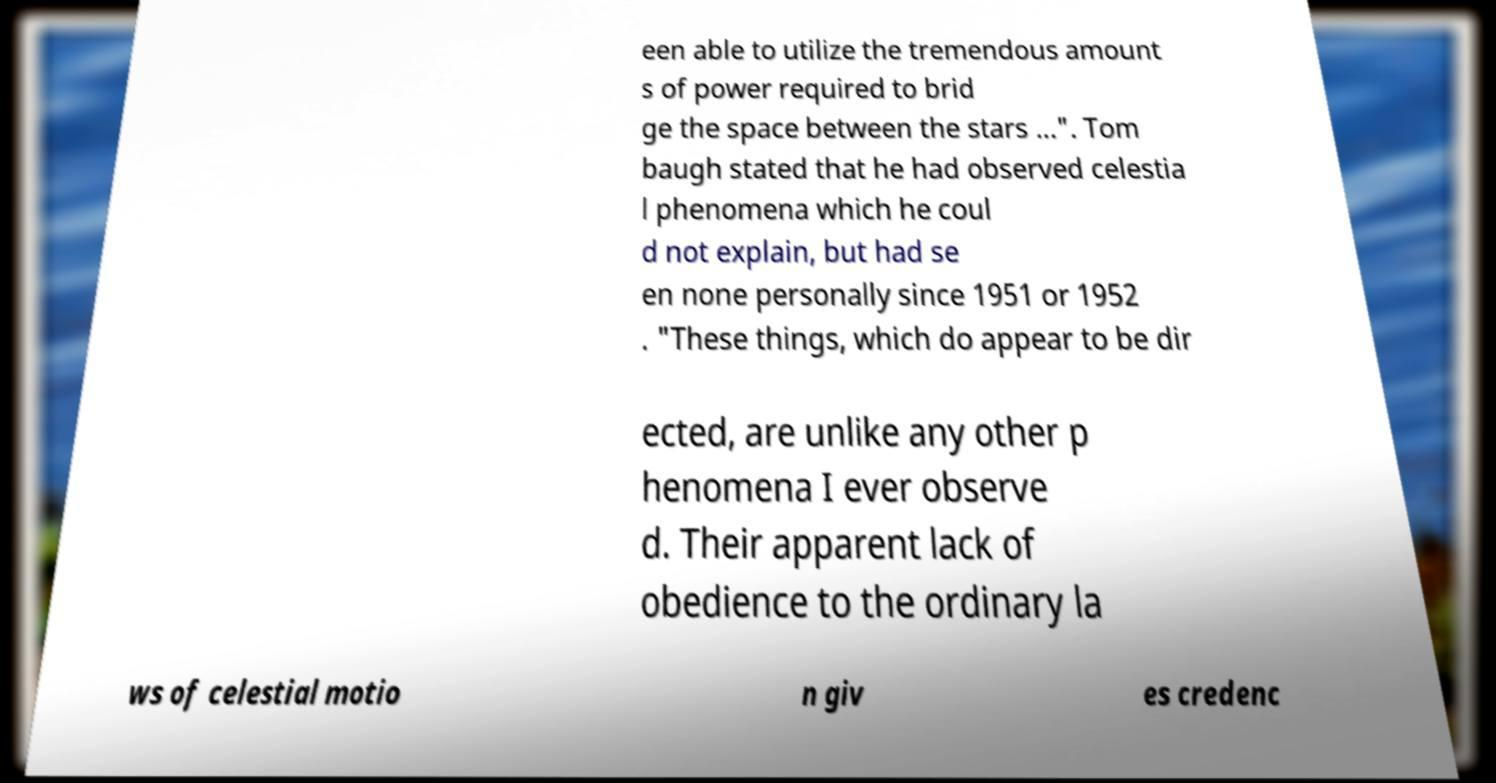What messages or text are displayed in this image? I need them in a readable, typed format. een able to utilize the tremendous amount s of power required to brid ge the space between the stars ...". Tom baugh stated that he had observed celestia l phenomena which he coul d not explain, but had se en none personally since 1951 or 1952 . "These things, which do appear to be dir ected, are unlike any other p henomena I ever observe d. Their apparent lack of obedience to the ordinary la ws of celestial motio n giv es credenc 